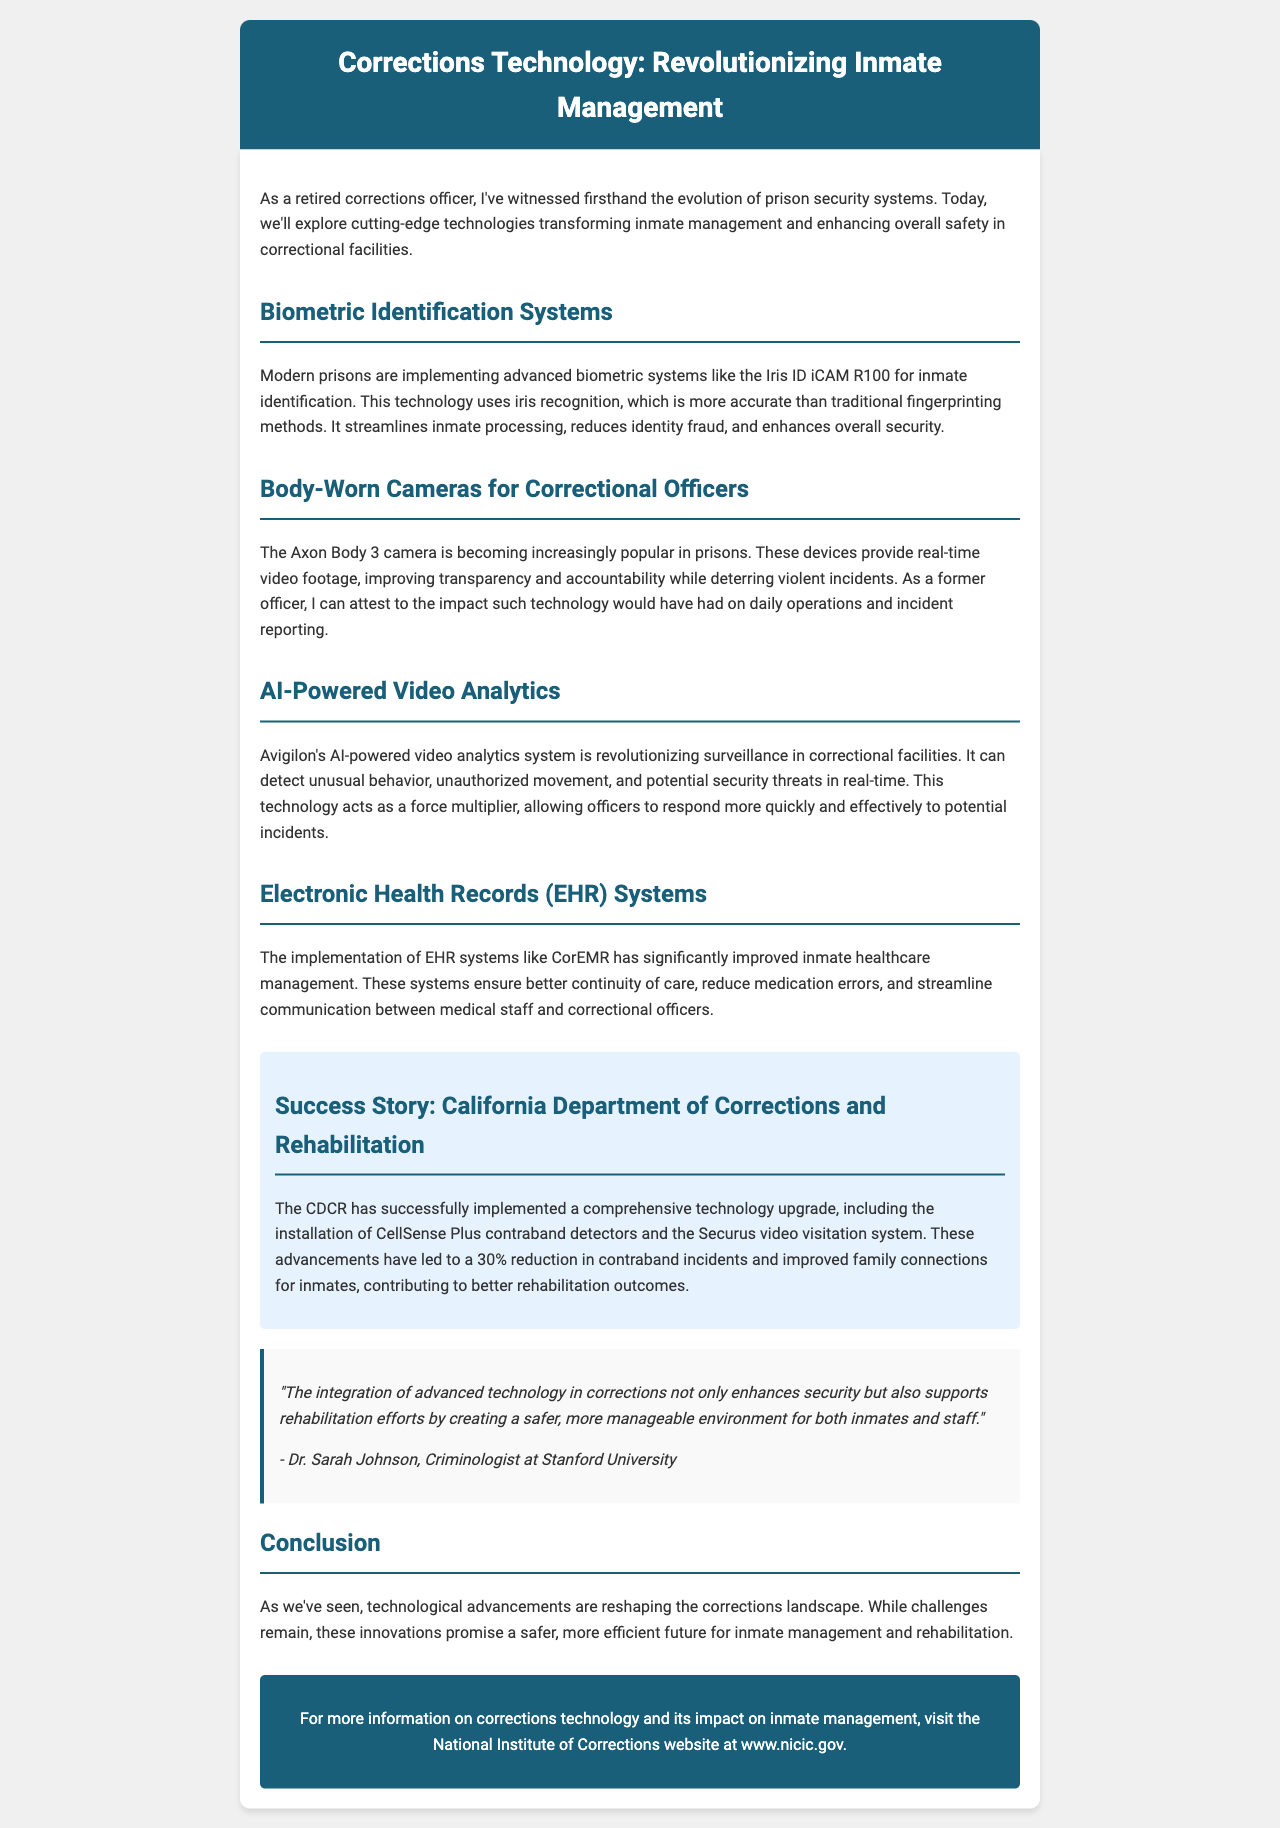What is the title of the newsletter? The title of the newsletter is provided at the beginning of the document.
Answer: Corrections Technology: Revolutionizing Inmate Management What biometric system is mentioned in the newsletter? The newsletter mentions a specific biometric system used for inmate identification in modern prisons.
Answer: Iris ID iCAM R100 Which body-worn camera is referenced? The newsletter includes information about a specific body-worn camera used by correctional officers.
Answer: Axon Body 3 What percentage reduction in contraband incidents is reported in the case study? The case study provides a specific percentage illustrating the success of technology upgrades in the California Department of Corrections.
Answer: 30% Who is the expert quoted in the newsletter? There is a specific expert quoted in the document, providing insight into the impact of technology in corrections.
Answer: Dr. Sarah Johnson What main advantage does AI-powered video analytics provide? The document states the main advantage of incorporating AI-powered video analytics in correctional facilities.
Answer: Detect unusual behavior What does EHR stand for? The newsletter discusses systems that improve healthcare management for inmates, abbreviated with a specific acronym.
Answer: Electronic Health Records What website is recommended for more information? A specific website is mentioned in the document for additional information related to corrections technology.
Answer: www.nicic.gov 